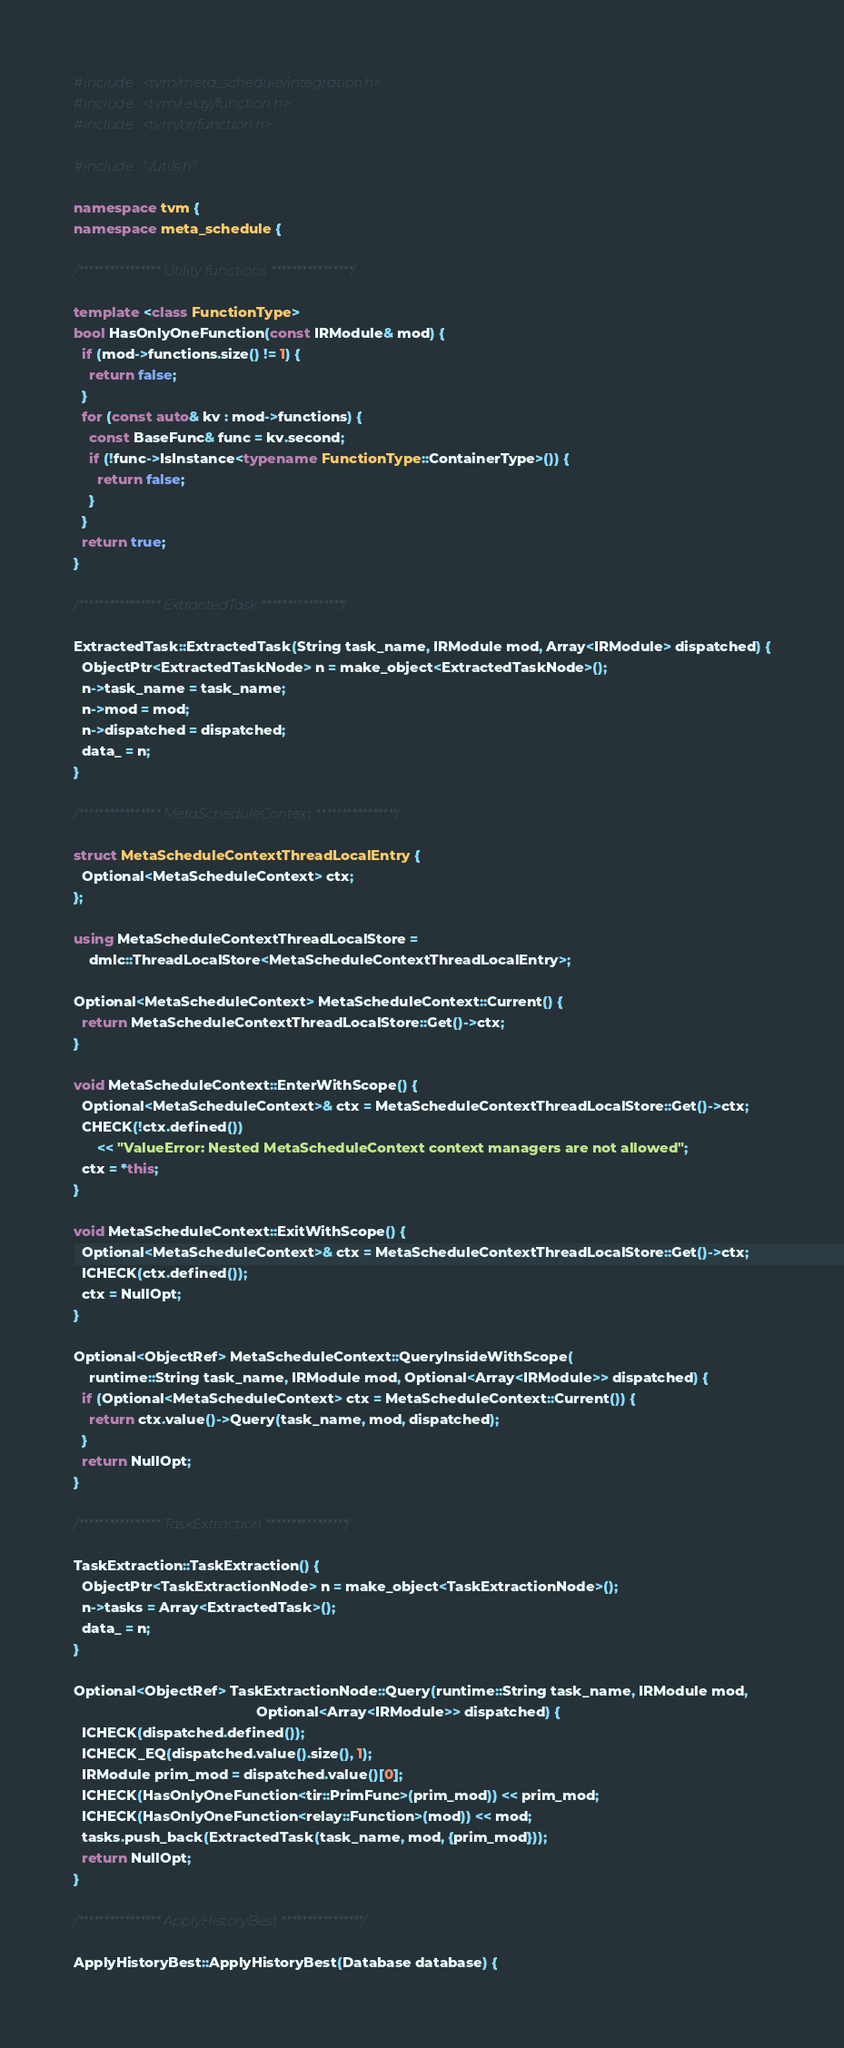<code> <loc_0><loc_0><loc_500><loc_500><_C++_>#include <tvm/meta_schedule/integration.h>
#include <tvm/relay/function.h>
#include <tvm/tir/function.h>

#include "./utils.h"

namespace tvm {
namespace meta_schedule {

/**************** Utility functions ****************/

template <class FunctionType>
bool HasOnlyOneFunction(const IRModule& mod) {
  if (mod->functions.size() != 1) {
    return false;
  }
  for (const auto& kv : mod->functions) {
    const BaseFunc& func = kv.second;
    if (!func->IsInstance<typename FunctionType::ContainerType>()) {
      return false;
    }
  }
  return true;
}

/**************** ExtractedTask ****************/

ExtractedTask::ExtractedTask(String task_name, IRModule mod, Array<IRModule> dispatched) {
  ObjectPtr<ExtractedTaskNode> n = make_object<ExtractedTaskNode>();
  n->task_name = task_name;
  n->mod = mod;
  n->dispatched = dispatched;
  data_ = n;
}

/**************** MetaScheduleContext ****************/

struct MetaScheduleContextThreadLocalEntry {
  Optional<MetaScheduleContext> ctx;
};

using MetaScheduleContextThreadLocalStore =
    dmlc::ThreadLocalStore<MetaScheduleContextThreadLocalEntry>;

Optional<MetaScheduleContext> MetaScheduleContext::Current() {
  return MetaScheduleContextThreadLocalStore::Get()->ctx;
}

void MetaScheduleContext::EnterWithScope() {
  Optional<MetaScheduleContext>& ctx = MetaScheduleContextThreadLocalStore::Get()->ctx;
  CHECK(!ctx.defined())
      << "ValueError: Nested MetaScheduleContext context managers are not allowed";
  ctx = *this;
}

void MetaScheduleContext::ExitWithScope() {
  Optional<MetaScheduleContext>& ctx = MetaScheduleContextThreadLocalStore::Get()->ctx;
  ICHECK(ctx.defined());
  ctx = NullOpt;
}

Optional<ObjectRef> MetaScheduleContext::QueryInsideWithScope(
    runtime::String task_name, IRModule mod, Optional<Array<IRModule>> dispatched) {
  if (Optional<MetaScheduleContext> ctx = MetaScheduleContext::Current()) {
    return ctx.value()->Query(task_name, mod, dispatched);
  }
  return NullOpt;
}

/**************** TaskExtraction ****************/

TaskExtraction::TaskExtraction() {
  ObjectPtr<TaskExtractionNode> n = make_object<TaskExtractionNode>();
  n->tasks = Array<ExtractedTask>();
  data_ = n;
}

Optional<ObjectRef> TaskExtractionNode::Query(runtime::String task_name, IRModule mod,
                                              Optional<Array<IRModule>> dispatched) {
  ICHECK(dispatched.defined());
  ICHECK_EQ(dispatched.value().size(), 1);
  IRModule prim_mod = dispatched.value()[0];
  ICHECK(HasOnlyOneFunction<tir::PrimFunc>(prim_mod)) << prim_mod;
  ICHECK(HasOnlyOneFunction<relay::Function>(mod)) << mod;
  tasks.push_back(ExtractedTask(task_name, mod, {prim_mod}));
  return NullOpt;
}

/**************** ApplyHistoryBest ****************/

ApplyHistoryBest::ApplyHistoryBest(Database database) {</code> 